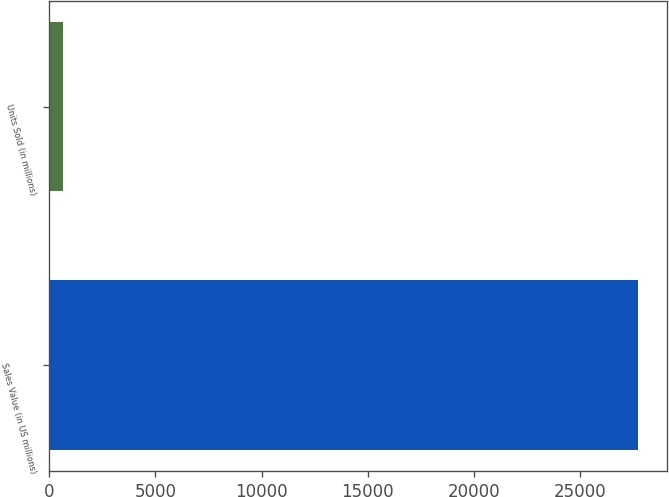Convert chart to OTSL. <chart><loc_0><loc_0><loc_500><loc_500><bar_chart><fcel>Sales Value (in US millions)<fcel>Units Sold (in millions)<nl><fcel>27714<fcel>645.5<nl></chart> 